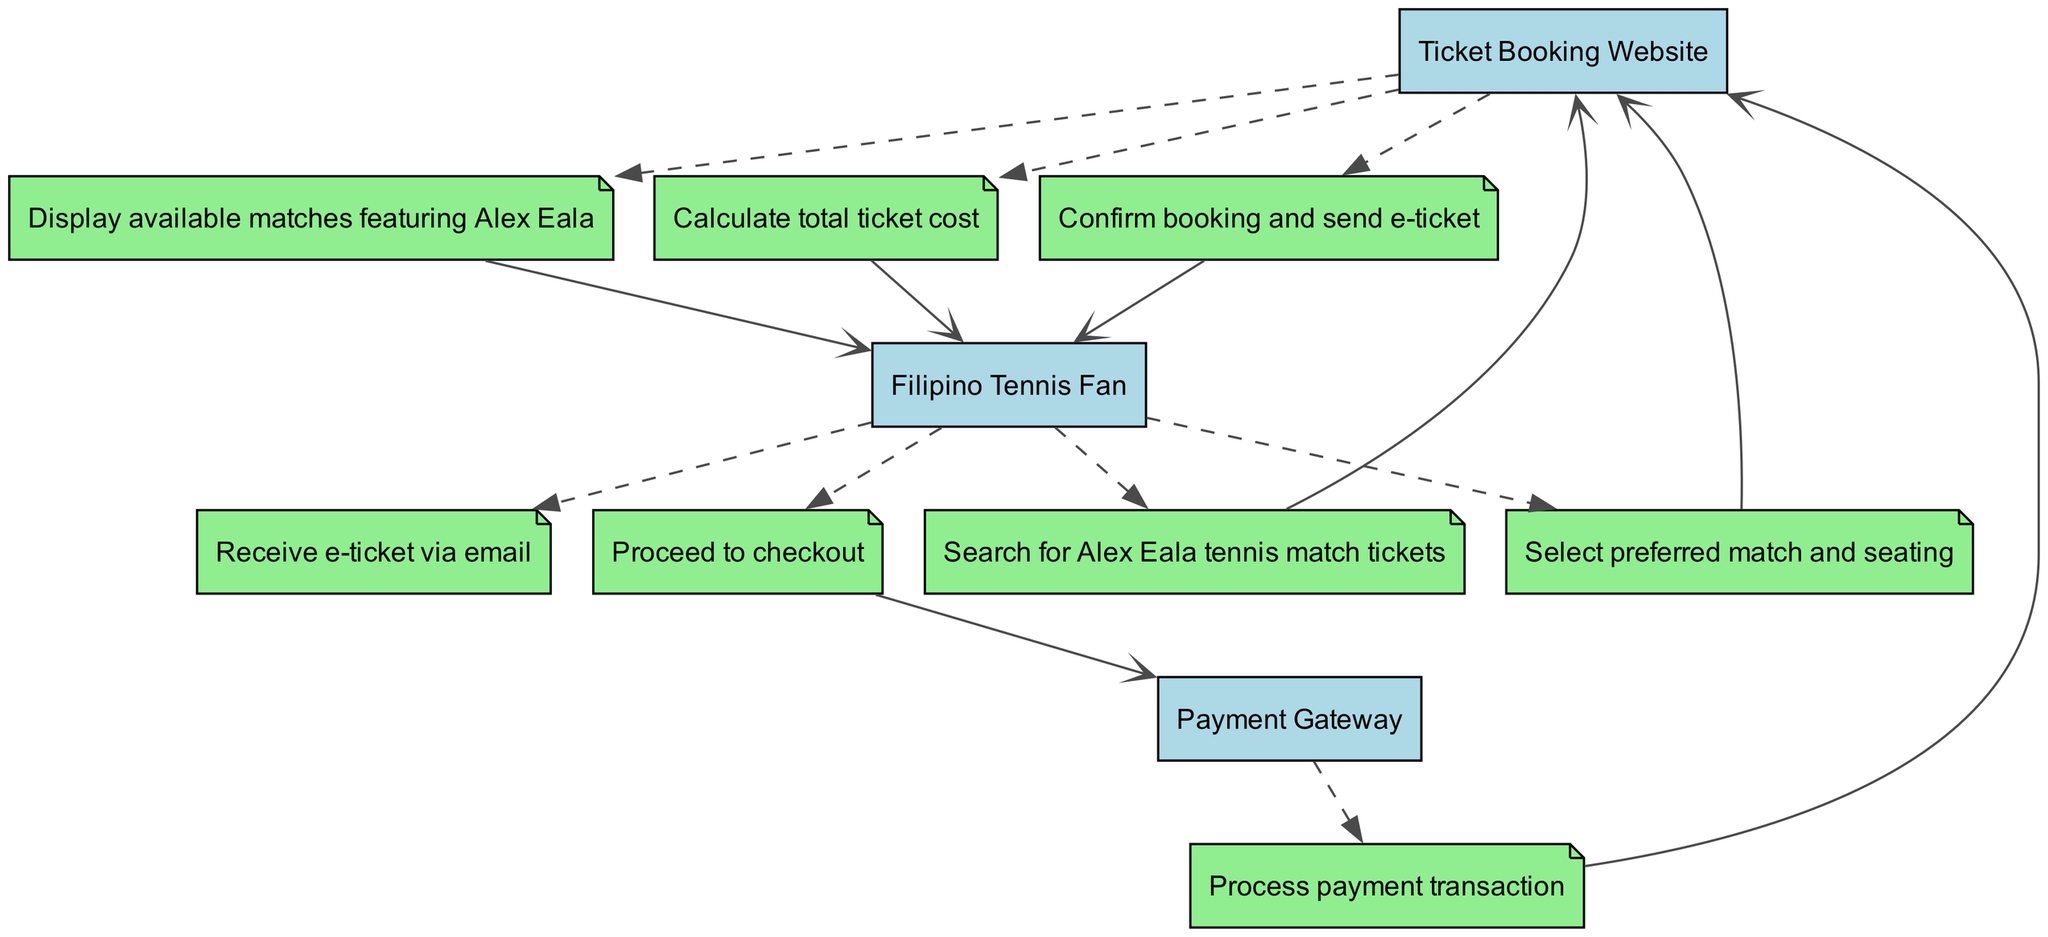What is the first action taken by the Filipino Tennis Fan? The first action listed in the diagram is "Search for Alex Eala tennis match tickets," which indicates that the Filipino Tennis Fan initiates the ticket booking process.
Answer: Search for Alex Eala tennis match tickets How many total participants are in the diagram? By analyzing the elements, the participants include the Filipino Tennis Fan, Ticket Booking Website, and Payment Gateway, totaling three distinct participants.
Answer: 3 What action comes after selecting preferred match and seating? After the action "Select preferred match and seating" from the Filipino Tennis Fan, the next action displayed is "Calculate total ticket cost" from the Ticket Booking Website.
Answer: Calculate total ticket cost Which participant sends the e-ticket? The "Ticket Booking Website" is responsible for confirming the booking and sending the e-ticket to the Filipino Tennis Fan.
Answer: Ticket Booking Website What action must the Filipino Tennis Fan take before receiving the e-ticket? The Filipino Tennis Fan must "Proceed to checkout" before they can receive the e-ticket after the booking is confirmed by the Ticket Booking Website.
Answer: Proceed to checkout Which action follows after the payment transaction is processed? After the "Process payment transaction" by the Payment Gateway, the next action is "Confirm booking and send e-ticket" by the Ticket Booking Website, indicating the completion of the transaction.
Answer: Confirm booking and send e-ticket What is the last action performed in the ticket booking process? The final action in the sequence is the Filipino Tennis Fan receiving the e-ticket via email, marking the completion of the booking process.
Answer: Receive e-ticket via email Name the participant who calculates the ticket cost. The participant responsible for calculating the ticket cost in the sequence is the Ticket Booking Website, as indicated after the Filipino Tennis Fan selects the match and seating.
Answer: Ticket Booking Website What type of edge connects the "Filipino Tennis Fan" to the "Process payment transaction"? The edge connecting the "Filipino Tennis Fan" to "Process payment transaction" is a dashed line, which indicates an action taken by the fan leading to a solid connection to the Payment Gateway for processing.
Answer: Dashed line 